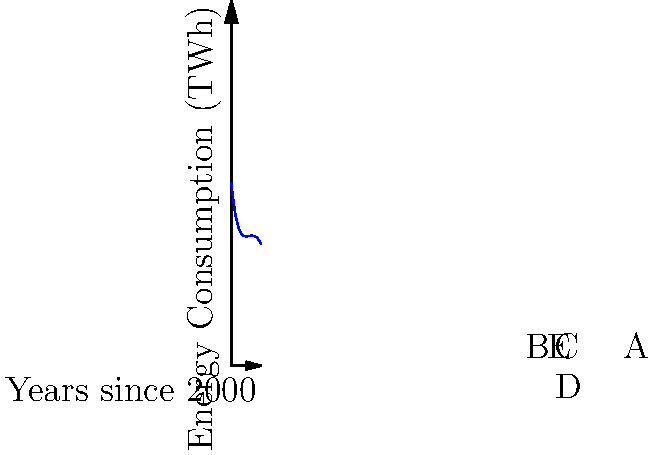The graph represents energy consumption patterns in a certain country from 2000 to 2010, modeled by a fourth-degree polynomial. As a veteran journalist in the energy sector, analyze the trend and identify the year when the consumption was at its lowest. How might this information influence your perspective on government energy policies and potential bailouts for the energy industry? To solve this problem, we need to follow these steps:

1. Understand the graph: The x-axis represents years since 2000, and the y-axis represents energy consumption in TWh.

2. Identify the lowest point: The lowest point on the curve represents the year with the lowest energy consumption.

3. Locate the minimum: The curve reaches its minimum between points A and B, closer to B.

4. Calculate the year: Point B is at x=3, which corresponds to 2003. The minimum appears to be slightly before this, around x=2.5.

5. Interpret the result: The lowest energy consumption occurred around 2002-2003.

6. Analysis for a skeptical journalist:
   a) The rapid decrease and subsequent increase in energy consumption could indicate economic instability or policy changes.
   b) This volatility might be used to argue against government bailouts, as the industry has shown resilience and ability to recover without intervention.
   c) The overall increasing trend after the low point could suggest that the energy sector is capable of self-correction and growth.
   d) The journalist might question whether any government policies implemented around 2002-2003 contributed to the low point and if they were effective or necessary.

7. Critical thinking: As a skeptical journalist, you might investigate:
   a) What factors led to the sharp decline and subsequent rise in energy consumption?
   b) Were there any government interventions during this period, and were they justified?
   c) How did energy companies adapt to these fluctuations without bailouts?
   d) What lessons can be learned from this period to inform current energy policies?
Answer: Lowest consumption around 2002-2003; suggests industry resilience without bailouts. 